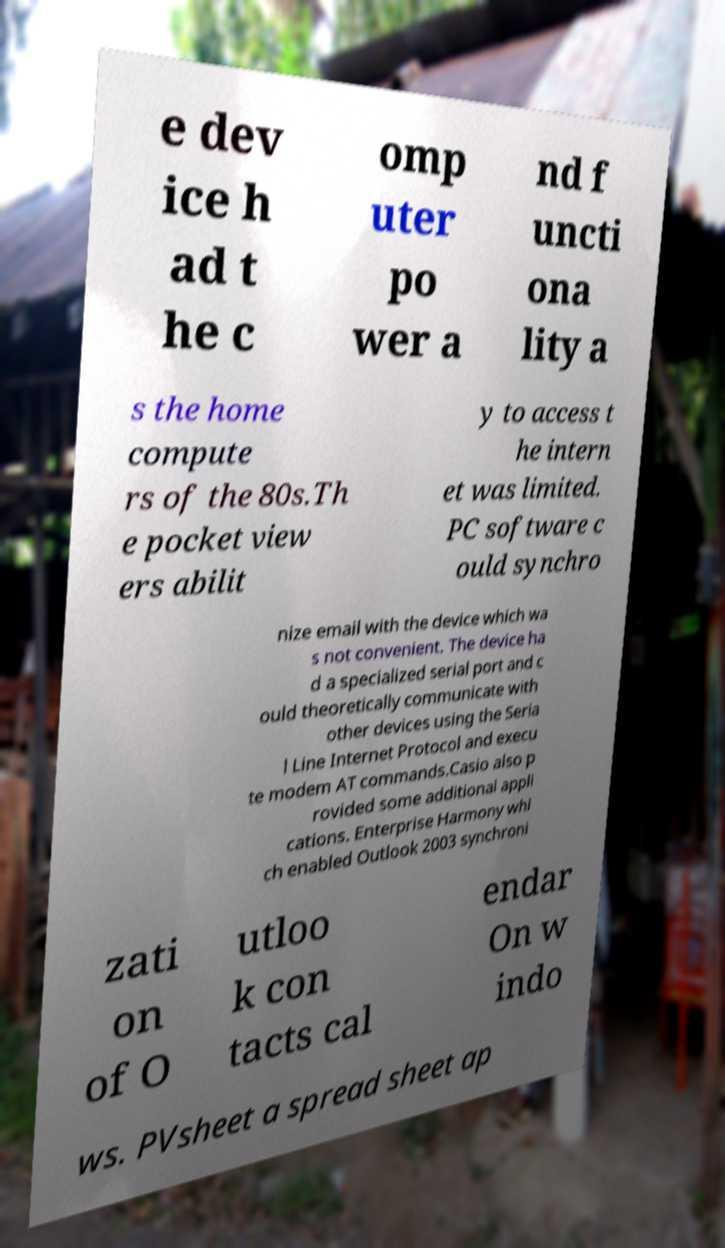Could you extract and type out the text from this image? e dev ice h ad t he c omp uter po wer a nd f uncti ona lity a s the home compute rs of the 80s.Th e pocket view ers abilit y to access t he intern et was limited. PC software c ould synchro nize email with the device which wa s not convenient. The device ha d a specialized serial port and c ould theoretically communicate with other devices using the Seria l Line Internet Protocol and execu te modem AT commands.Casio also p rovided some additional appli cations. Enterprise Harmony whi ch enabled Outlook 2003 synchroni zati on of O utloo k con tacts cal endar On w indo ws. PVsheet a spread sheet ap 